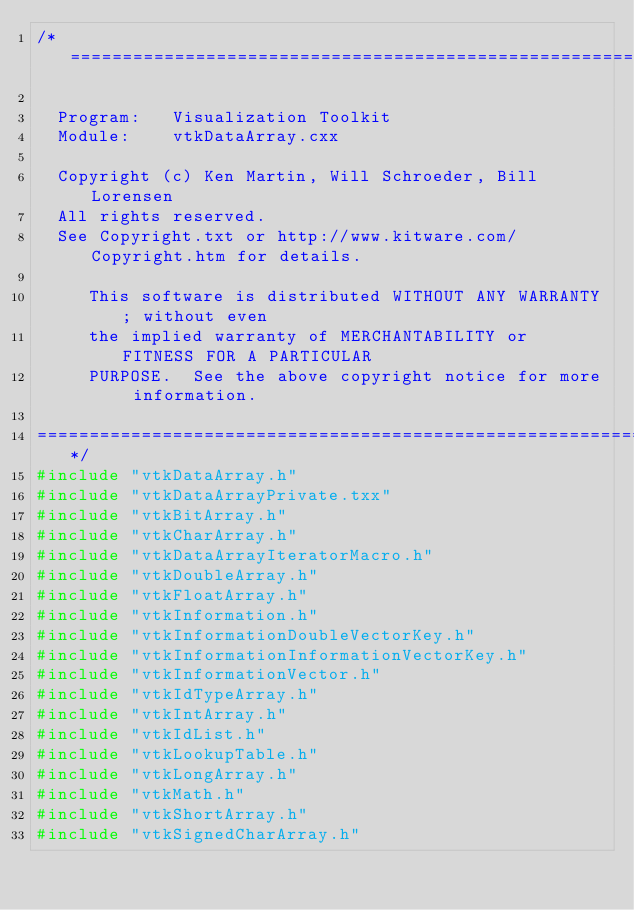<code> <loc_0><loc_0><loc_500><loc_500><_C++_>/*=========================================================================

  Program:   Visualization Toolkit
  Module:    vtkDataArray.cxx

  Copyright (c) Ken Martin, Will Schroeder, Bill Lorensen
  All rights reserved.
  See Copyright.txt or http://www.kitware.com/Copyright.htm for details.

     This software is distributed WITHOUT ANY WARRANTY; without even
     the implied warranty of MERCHANTABILITY or FITNESS FOR A PARTICULAR
     PURPOSE.  See the above copyright notice for more information.

=========================================================================*/
#include "vtkDataArray.h"
#include "vtkDataArrayPrivate.txx"
#include "vtkBitArray.h"
#include "vtkCharArray.h"
#include "vtkDataArrayIteratorMacro.h"
#include "vtkDoubleArray.h"
#include "vtkFloatArray.h"
#include "vtkInformation.h"
#include "vtkInformationDoubleVectorKey.h"
#include "vtkInformationInformationVectorKey.h"
#include "vtkInformationVector.h"
#include "vtkIdTypeArray.h"
#include "vtkIntArray.h"
#include "vtkIdList.h"
#include "vtkLookupTable.h"
#include "vtkLongArray.h"
#include "vtkMath.h"
#include "vtkShortArray.h"
#include "vtkSignedCharArray.h"</code> 